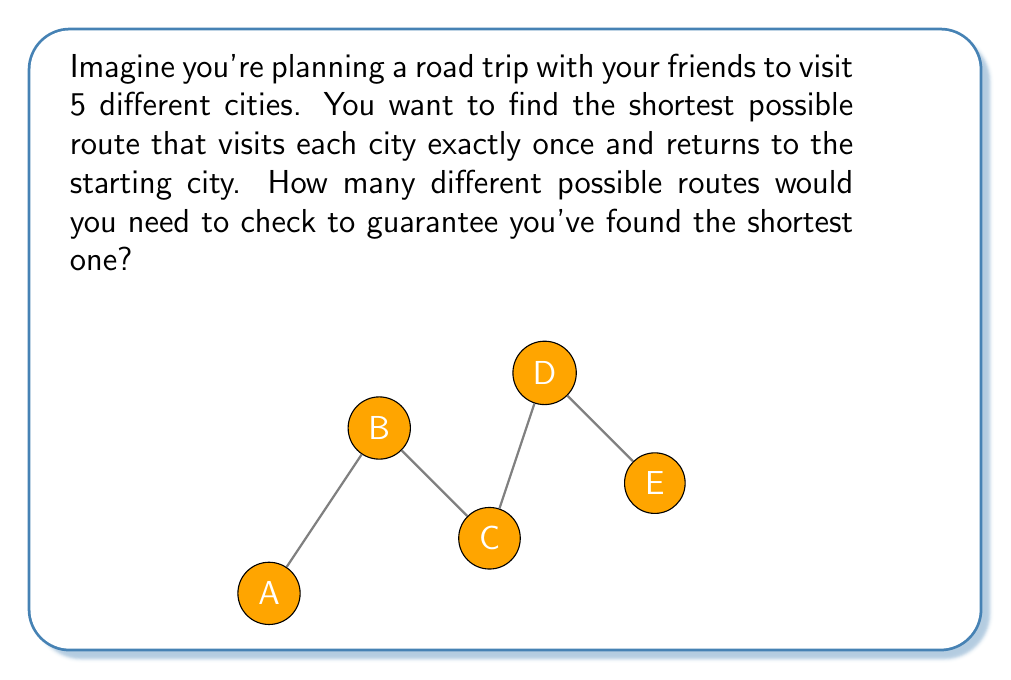Could you help me with this problem? This problem is an example of the Traveling Salesman Problem (TSP), which is a classic NP-complete problem. Let's break down the solution:

1) First, we need to understand what NP-completeness means:
   - NP stands for "Nondeterministic Polynomial time"
   - NP-complete problems are the hardest problems in NP
   - There's no known efficient (polynomial-time) algorithm to solve NP-complete problems

2) For the TSP with 5 cities:
   - We start at any city (let's say A)
   - We need to arrange the other 4 cities in all possible orders

3) The number of possible arrangements is a permutation:
   $$(n-1)! = 4! = 4 \times 3 \times 2 \times 1 = 24$$

4) However, we can also traverse each route in reverse, so we need to divide by 2:
   $$\frac{(n-1)!}{2} = \frac{24}{2} = 12$$

5) This means we need to check 12 different routes to guarantee we've found the shortest one.

6) As the number of cities increases, the number of routes grows factorially:
   - For 10 cities: $\frac{9!}{2} = 181,440$ routes
   - For 20 cities: $\frac{19!}{2} \approx 6 \times 10^{16}$ routes

This exponential growth is why TSP and other NP-complete problems are considered computationally intractable for large inputs, demonstrating the challenges of NP-completeness in everyday scenarios.
Answer: 12 routes 